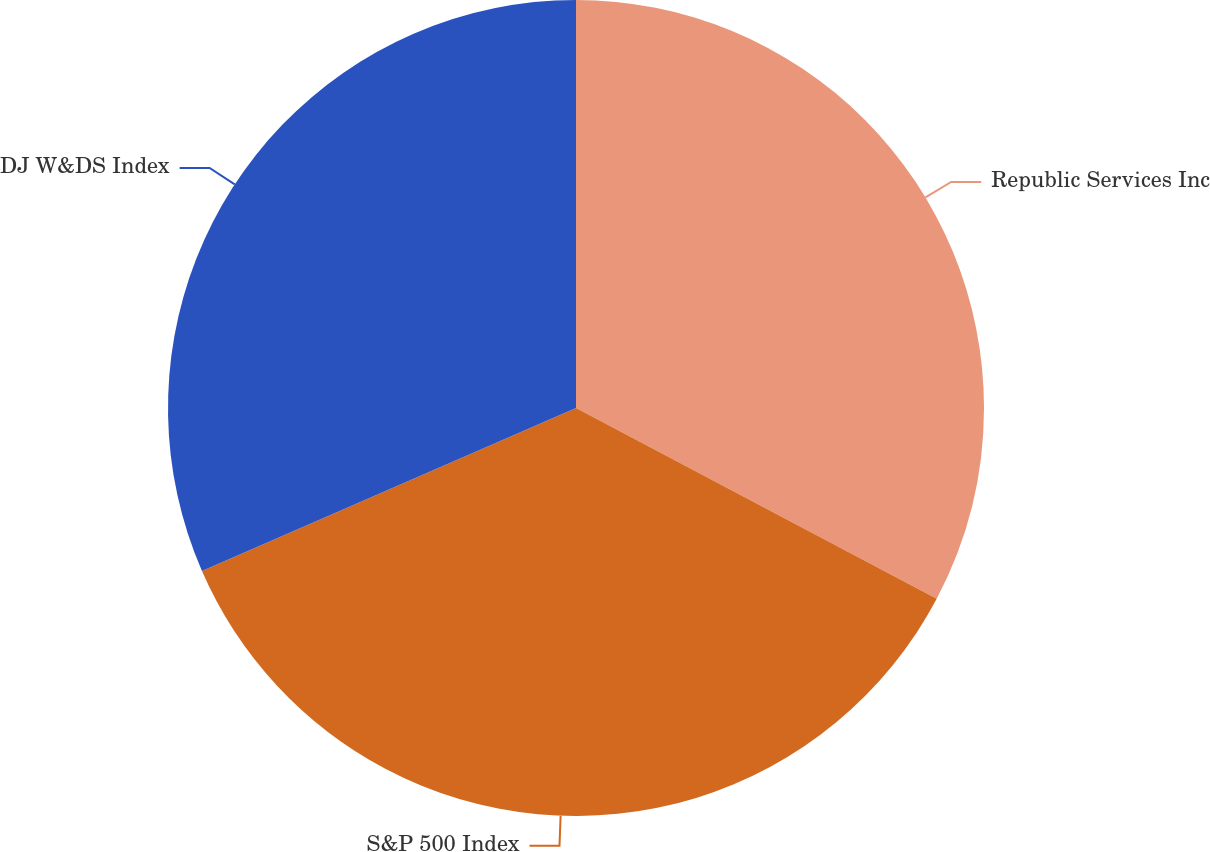Convert chart. <chart><loc_0><loc_0><loc_500><loc_500><pie_chart><fcel>Republic Services Inc<fcel>S&P 500 Index<fcel>DJ W&DS Index<nl><fcel>32.74%<fcel>35.72%<fcel>31.54%<nl></chart> 